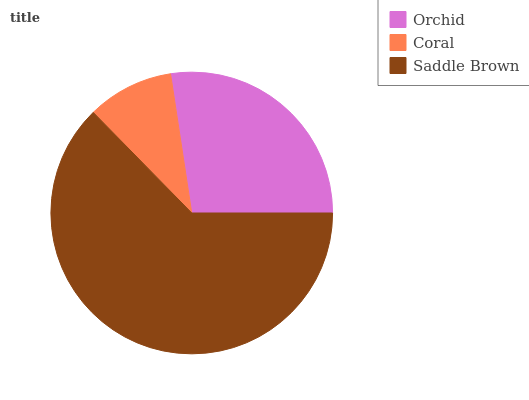Is Coral the minimum?
Answer yes or no. Yes. Is Saddle Brown the maximum?
Answer yes or no. Yes. Is Saddle Brown the minimum?
Answer yes or no. No. Is Coral the maximum?
Answer yes or no. No. Is Saddle Brown greater than Coral?
Answer yes or no. Yes. Is Coral less than Saddle Brown?
Answer yes or no. Yes. Is Coral greater than Saddle Brown?
Answer yes or no. No. Is Saddle Brown less than Coral?
Answer yes or no. No. Is Orchid the high median?
Answer yes or no. Yes. Is Orchid the low median?
Answer yes or no. Yes. Is Coral the high median?
Answer yes or no. No. Is Saddle Brown the low median?
Answer yes or no. No. 